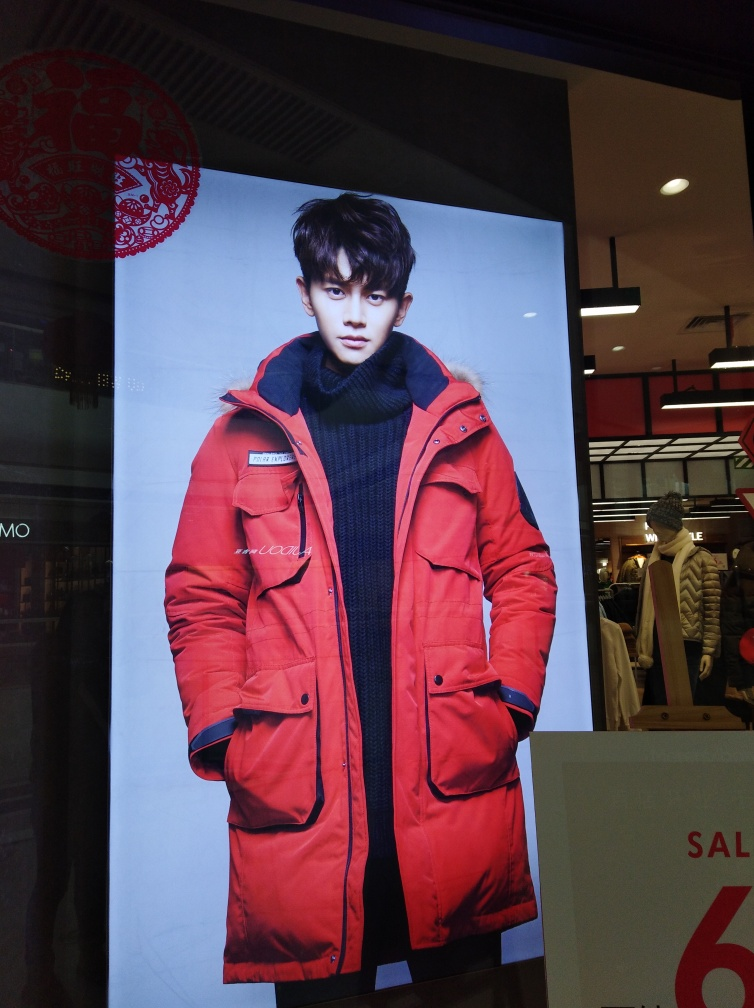Is there any noise present in the image? While the image is quite clear, there is some visible noise in the form of reflections and light artifacts, which can be noticed on the glossy surfaces within the picture. 